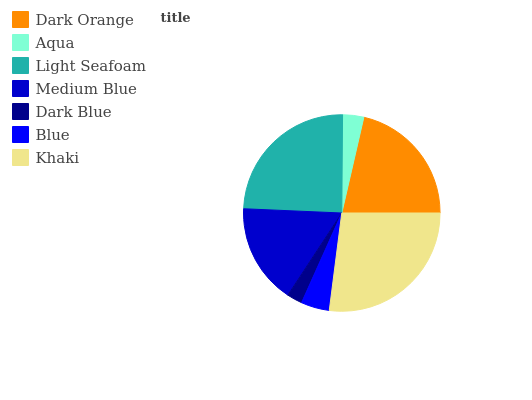Is Dark Blue the minimum?
Answer yes or no. Yes. Is Khaki the maximum?
Answer yes or no. Yes. Is Aqua the minimum?
Answer yes or no. No. Is Aqua the maximum?
Answer yes or no. No. Is Dark Orange greater than Aqua?
Answer yes or no. Yes. Is Aqua less than Dark Orange?
Answer yes or no. Yes. Is Aqua greater than Dark Orange?
Answer yes or no. No. Is Dark Orange less than Aqua?
Answer yes or no. No. Is Medium Blue the high median?
Answer yes or no. Yes. Is Medium Blue the low median?
Answer yes or no. Yes. Is Blue the high median?
Answer yes or no. No. Is Aqua the low median?
Answer yes or no. No. 